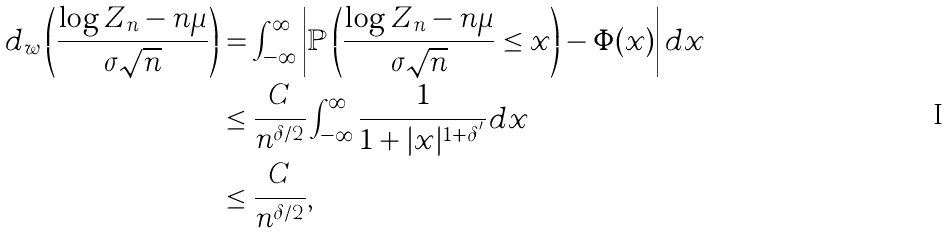<formula> <loc_0><loc_0><loc_500><loc_500>d _ { w } \left ( \frac { \log Z _ { n } - n \mu } { \sigma \sqrt { n } } \right ) & = \int _ { - \infty } ^ { \infty } \left | \mathbb { P } \left ( \frac { \log Z _ { n } - n \mu } { \sigma \sqrt { n } } \leq x \right ) - \Phi ( x ) \right | d x \\ & \leq \frac { C } { n ^ { \delta / 2 } } \int _ { - \infty } ^ { \infty } \frac { 1 } { 1 + | x | ^ { 1 + \delta ^ { ^ { \prime } } } } d x \\ & \leq \frac { C } { n ^ { \delta / 2 } } ,</formula> 